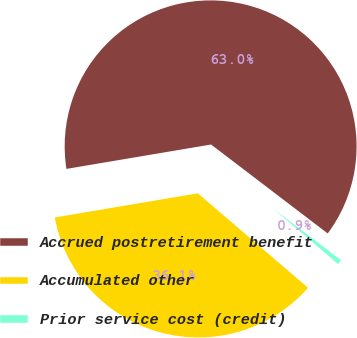<chart> <loc_0><loc_0><loc_500><loc_500><pie_chart><fcel>Accrued postretirement benefit<fcel>Accumulated other<fcel>Prior service cost (credit)<nl><fcel>63.03%<fcel>36.06%<fcel>0.91%<nl></chart> 